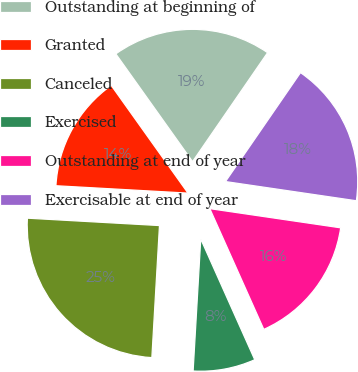Convert chart to OTSL. <chart><loc_0><loc_0><loc_500><loc_500><pie_chart><fcel>Outstanding at beginning of<fcel>Granted<fcel>Canceled<fcel>Exercised<fcel>Outstanding at end of year<fcel>Exercisable at end of year<nl><fcel>19.45%<fcel>14.26%<fcel>24.97%<fcel>7.61%<fcel>15.99%<fcel>17.72%<nl></chart> 